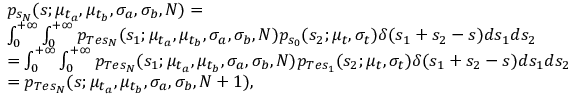<formula> <loc_0><loc_0><loc_500><loc_500>\begin{array} { r l } & { p _ { s _ { N } } ( s ; \mu _ { t _ { a } } , \mu _ { t _ { b } } , \sigma _ { a } , \sigma _ { b } , N ) = } \\ & { \int _ { 0 } ^ { + \infty } \int _ { 0 } ^ { + \infty } p _ { T e s _ { N } } ( s _ { 1 } ; \mu _ { t _ { a } } , \mu _ { t _ { b } } , \sigma _ { a } , \sigma _ { b } , N ) p _ { s _ { 0 } } ( s _ { 2 } ; \mu _ { t } , \sigma _ { t } ) \delta ( s _ { 1 } + s _ { 2 } - s ) d s _ { 1 } d s _ { 2 } } \\ & { = \int _ { 0 } ^ { + \infty } \int _ { 0 } ^ { + \infty } p _ { T e s _ { N } } ( s _ { 1 } ; \mu _ { t _ { a } } , \mu _ { t _ { b } } , \sigma _ { a } , \sigma _ { b } , N ) p _ { T e s _ { 1 } } ( s _ { 2 } ; \mu _ { t } , \sigma _ { t } ) \delta ( s _ { 1 } + s _ { 2 } - s ) d s _ { 1 } d s _ { 2 } } \\ & { = p _ { T e s _ { N } } ( s ; \mu _ { t _ { a } } , \mu _ { t _ { b } } , \sigma _ { a } , \sigma _ { b } , N + 1 ) , } \end{array}</formula> 